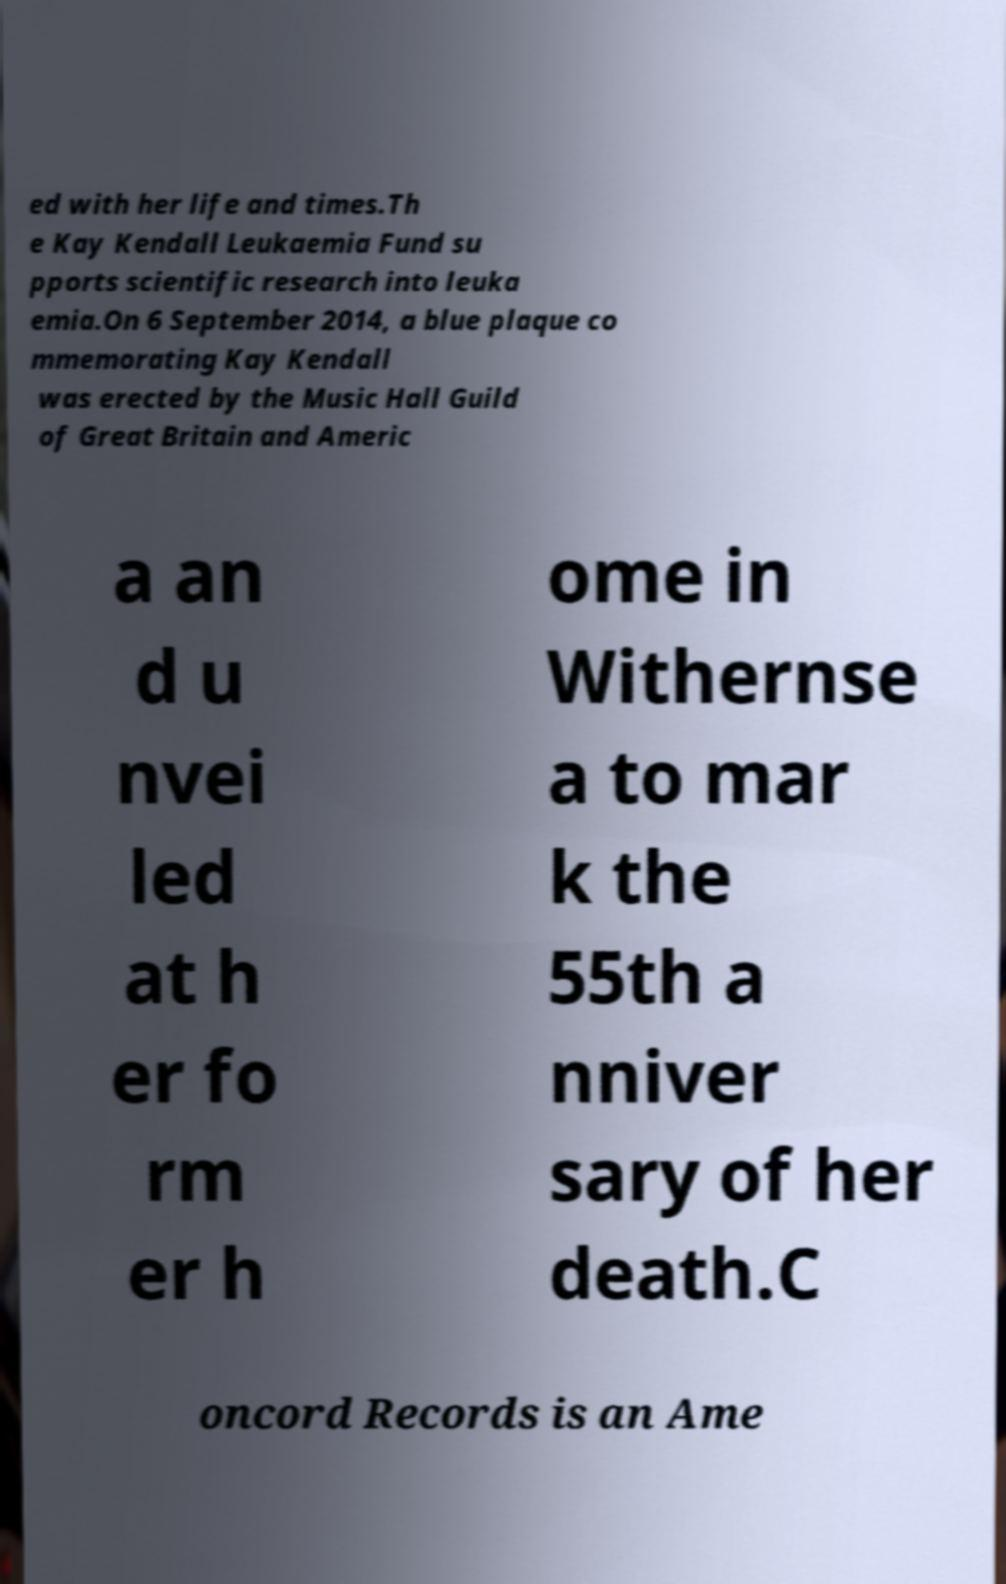I need the written content from this picture converted into text. Can you do that? ed with her life and times.Th e Kay Kendall Leukaemia Fund su pports scientific research into leuka emia.On 6 September 2014, a blue plaque co mmemorating Kay Kendall was erected by the Music Hall Guild of Great Britain and Americ a an d u nvei led at h er fo rm er h ome in Withernse a to mar k the 55th a nniver sary of her death.C oncord Records is an Ame 